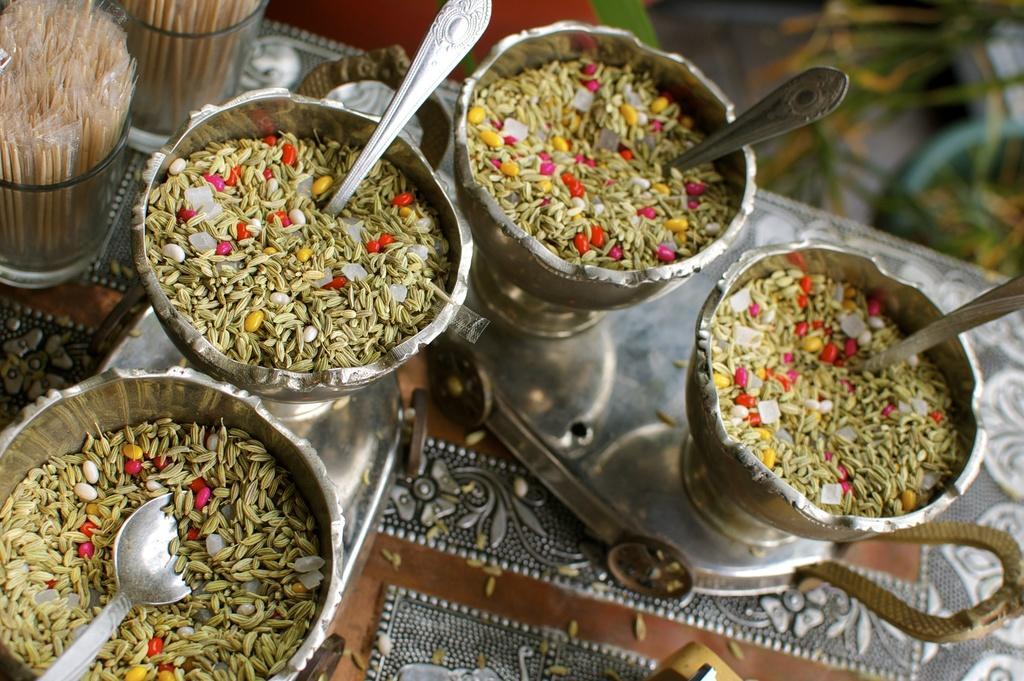Please provide a concise description of this image. In this image, we can see few bowls filled with mouth fresheners and spoons. These are placed on the tray. Left side top corner, we can see toothpicks in two glasses. 